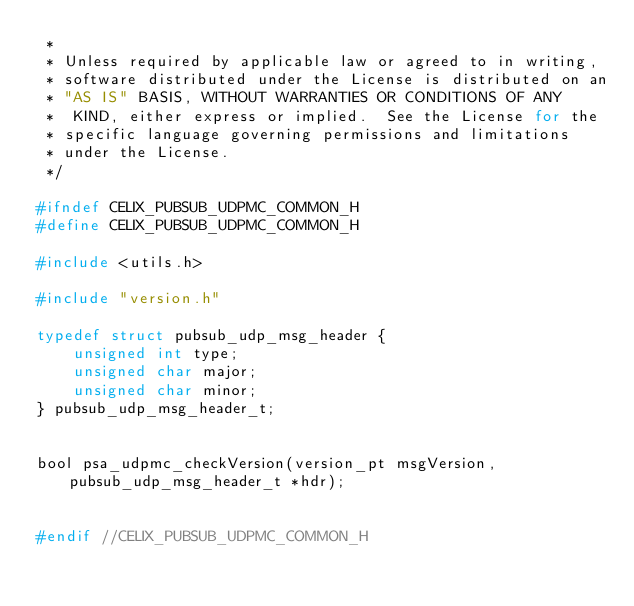Convert code to text. <code><loc_0><loc_0><loc_500><loc_500><_C_> *
 * Unless required by applicable law or agreed to in writing,
 * software distributed under the License is distributed on an
 * "AS IS" BASIS, WITHOUT WARRANTIES OR CONDITIONS OF ANY
 *  KIND, either express or implied.  See the License for the
 * specific language governing permissions and limitations
 * under the License.
 */

#ifndef CELIX_PUBSUB_UDPMC_COMMON_H
#define CELIX_PUBSUB_UDPMC_COMMON_H

#include <utils.h>

#include "version.h"

typedef struct pubsub_udp_msg_header {
    unsigned int type;
    unsigned char major;
    unsigned char minor;
} pubsub_udp_msg_header_t;


bool psa_udpmc_checkVersion(version_pt msgVersion, pubsub_udp_msg_header_t *hdr);


#endif //CELIX_PUBSUB_UDPMC_COMMON_H
</code> 